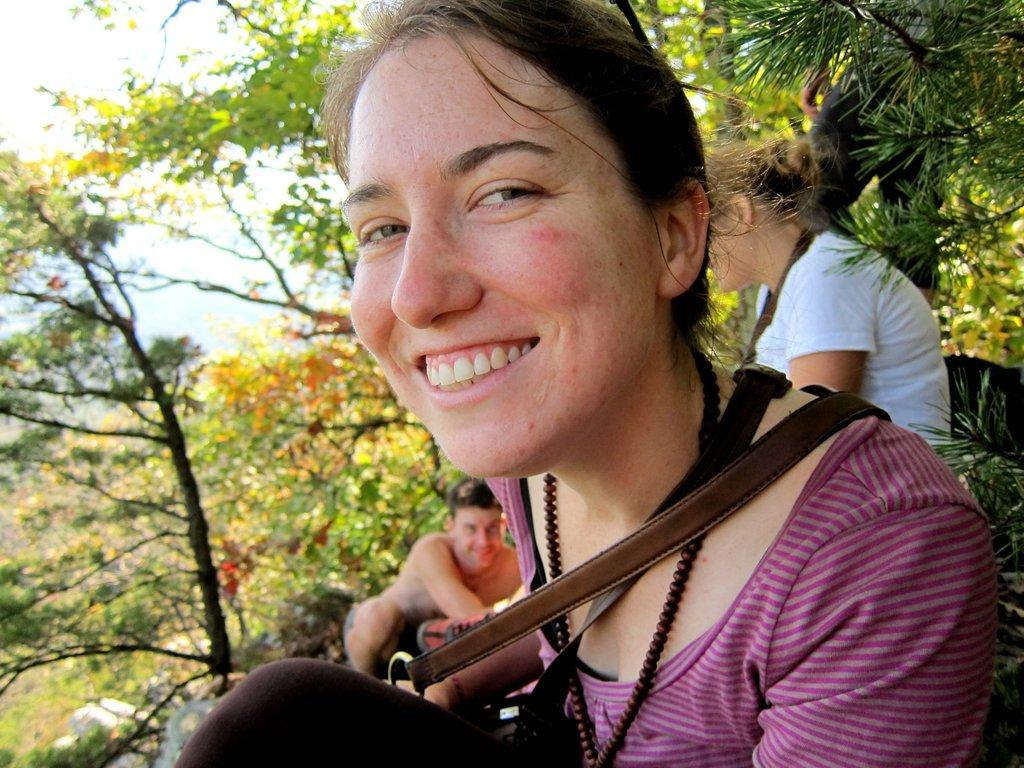Who or what can be seen in the image? There are people in the image. What type of natural elements are present in the image? There are trees in the image. What type of boats are being used for the feast in the image? There is no mention of boats or a feast in the image; it only features people and trees. 